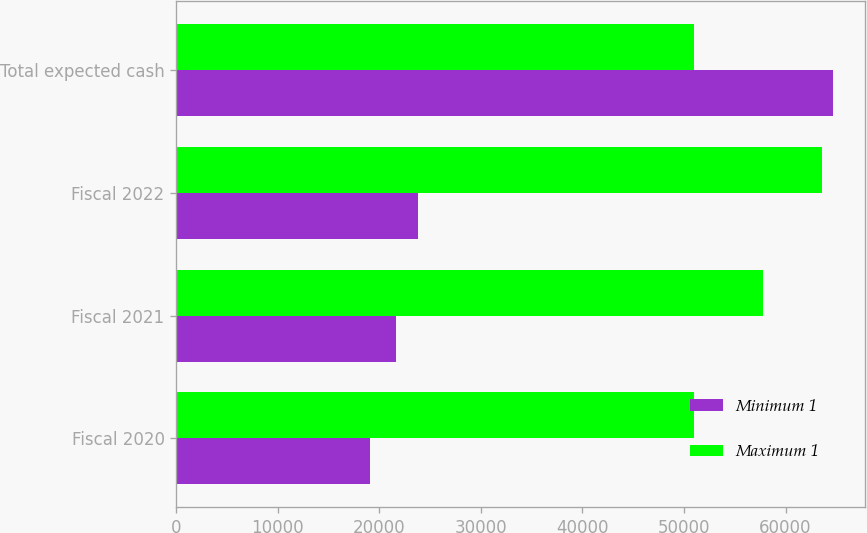Convert chart. <chart><loc_0><loc_0><loc_500><loc_500><stacked_bar_chart><ecel><fcel>Fiscal 2020<fcel>Fiscal 2021<fcel>Fiscal 2022<fcel>Total expected cash<nl><fcel>Minimum 1<fcel>19121<fcel>21665<fcel>23851<fcel>64637<nl><fcel>Maximum 1<fcel>50988<fcel>57773<fcel>63602<fcel>50988<nl></chart> 